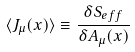<formula> <loc_0><loc_0><loc_500><loc_500>\langle J _ { \mu } ( x ) \rangle \equiv \frac { \delta S _ { e f f } } { \delta A _ { \mu } ( x ) }</formula> 